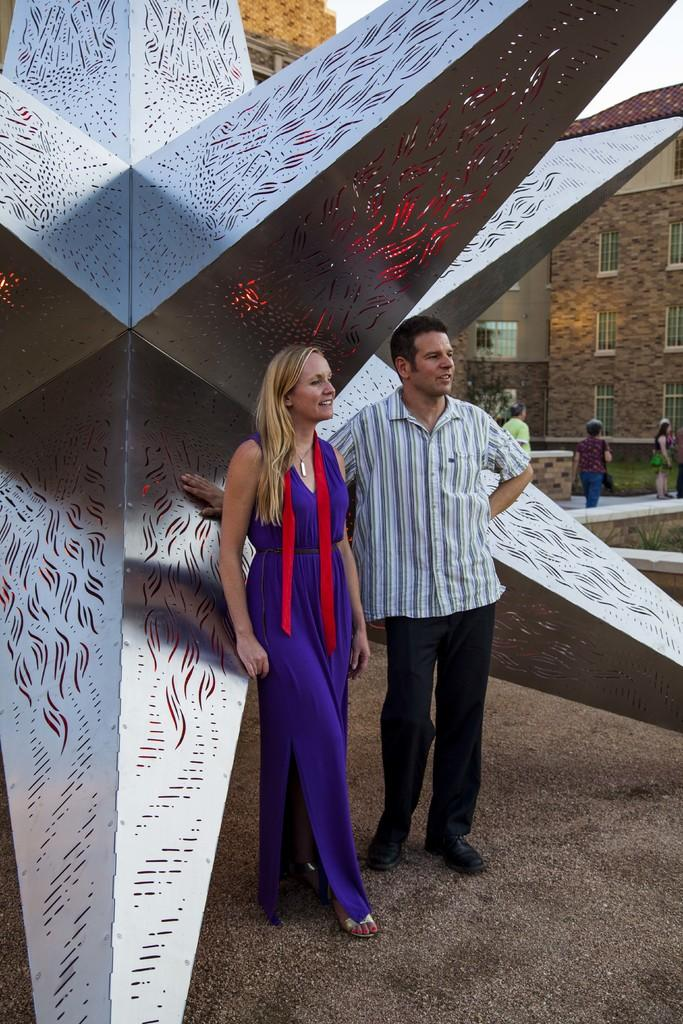What can be seen in the image involving human presence? There are people standing in the image. Where are the people standing? The people are standing on the floor. What type of artwork is present in the image? There is a sculpture in the image. What type of man-made structures can be seen in the image? There are buildings in the image. What part of the natural environment is visible in the image? The sky is visible in the image. What type of cracker is being used to create the sculpture in the image? There is no cracker present in the image, and the sculpture is not made of crackers. What type of wilderness can be seen in the background of the image? There is no wilderness present in the image; it features people, a sculpture, buildings, and the sky. 